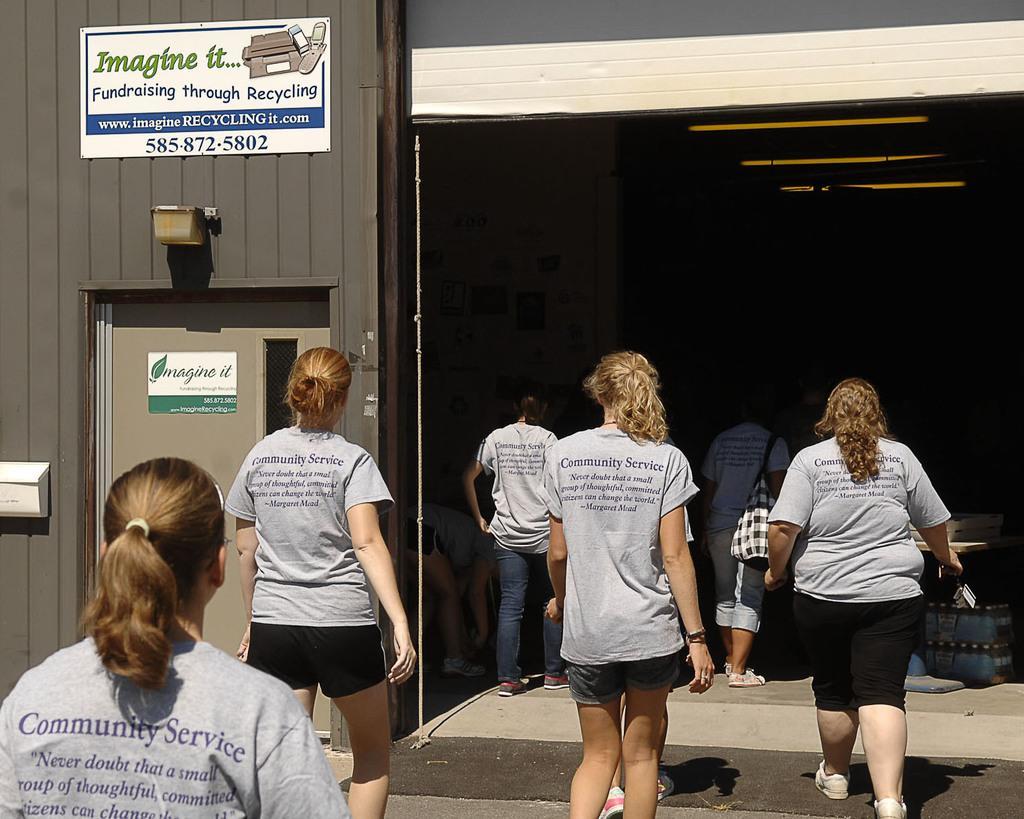How would you summarize this image in a sentence or two? In the picture I can see few persons standing and wearing grey color T-shirts which has something written on it and there is a sheet which has something written on it is attached on the wall in the left top corner. 